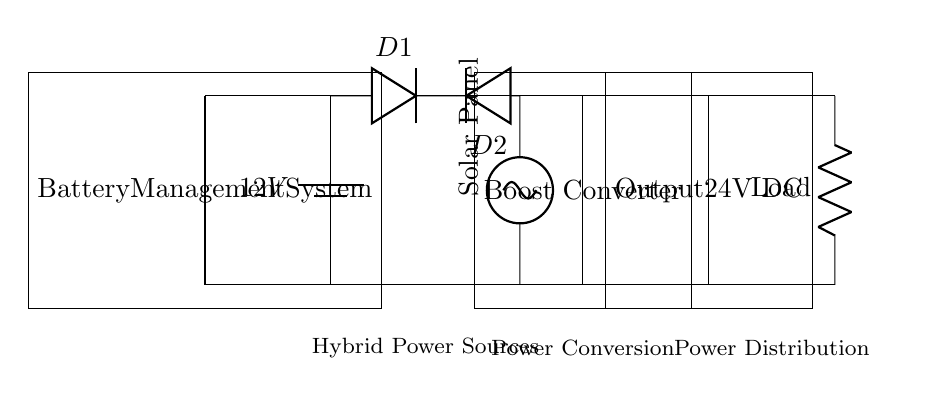What is the primary voltage source in this circuit? The primary voltage source is a 12V battery, which can be identified at the leftmost side of the diagram.
Answer: 12V battery What is the purpose of the boost converter? The boost converter increases the voltage from 12V to 24V, which is evident in the output section labeled as 24V DC.
Answer: Increase voltage What components are used to manage input from the solar panel and battery? The circuit uses diodes labeled D1 and D2, which are responsible for allowing current to flow in one direction and preventing backflow, ensuring safe management of inputs.
Answer: Diodes What voltage does the output provide for the load? The output section specifies that it provides 24V DC, which is clear from the label directly above the output component.
Answer: 24V DC How is the battery management system connected to the circuit? The battery management system is connected to both the battery and the solar panel, which is shown in the connections leading from the system to each component.
Answer: Connected to battery and solar panel What is the main function of the hybrid power sources in this circuit? The hybrid power sources, which include the solar panel and battery, supply electricity to ensure that the load receives power continuously, even when one source is not available.
Answer: Continuous power supply 